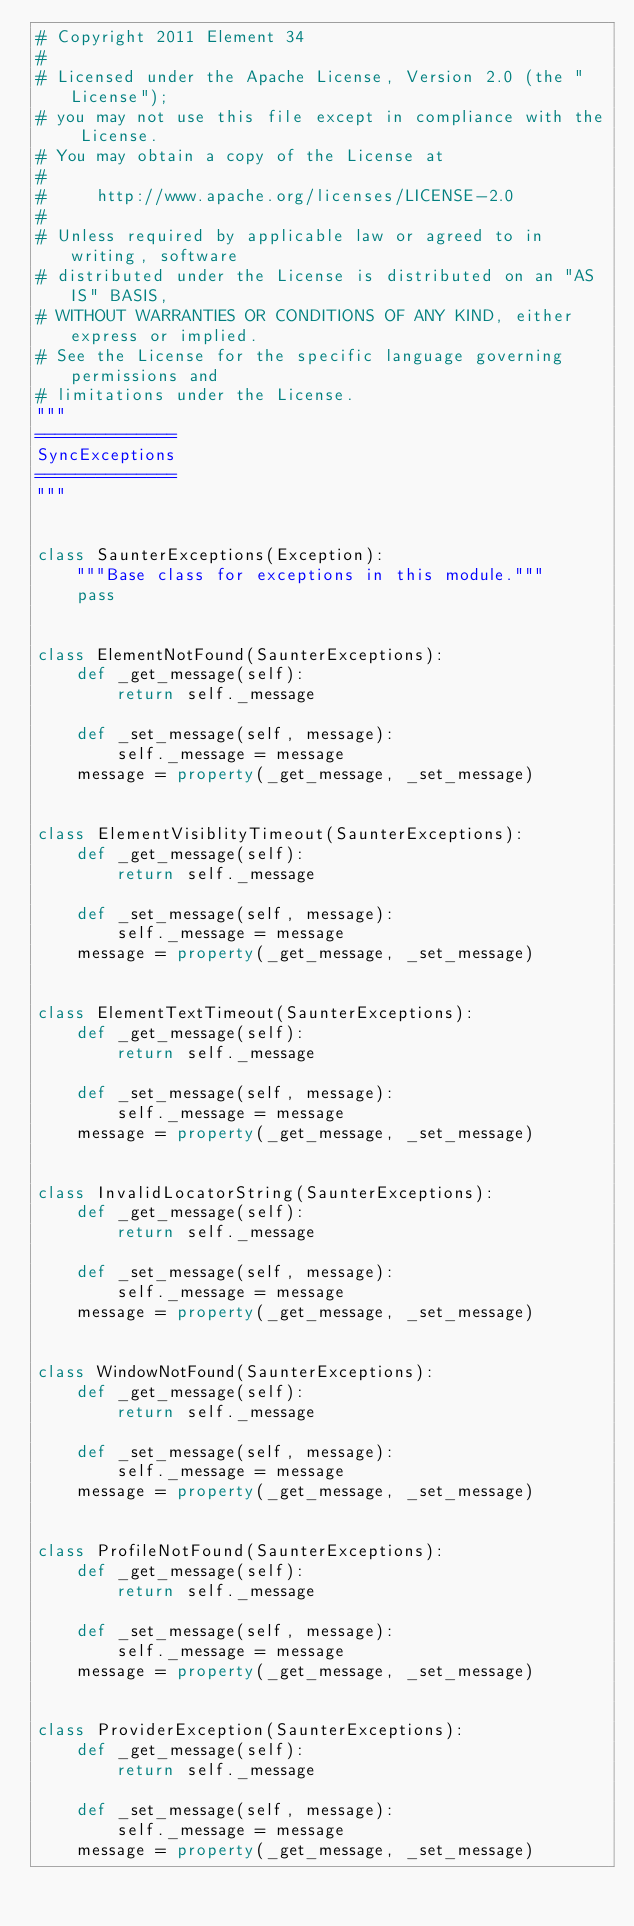Convert code to text. <code><loc_0><loc_0><loc_500><loc_500><_Python_># Copyright 2011 Element 34
#
# Licensed under the Apache License, Version 2.0 (the "License");
# you may not use this file except in compliance with the License.
# You may obtain a copy of the License at
#
#     http://www.apache.org/licenses/LICENSE-2.0
#
# Unless required by applicable law or agreed to in writing, software
# distributed under the License is distributed on an "AS IS" BASIS,
# WITHOUT WARRANTIES OR CONDITIONS OF ANY KIND, either express or implied.
# See the License for the specific language governing permissions and
# limitations under the License.
"""
==============
SyncExceptions
==============
"""


class SaunterExceptions(Exception):
    """Base class for exceptions in this module."""
    pass


class ElementNotFound(SaunterExceptions):
    def _get_message(self):
        return self._message

    def _set_message(self, message):
        self._message = message
    message = property(_get_message, _set_message)


class ElementVisiblityTimeout(SaunterExceptions):
    def _get_message(self):
        return self._message

    def _set_message(self, message):
        self._message = message
    message = property(_get_message, _set_message)


class ElementTextTimeout(SaunterExceptions):
    def _get_message(self):
        return self._message

    def _set_message(self, message):
        self._message = message
    message = property(_get_message, _set_message)


class InvalidLocatorString(SaunterExceptions):
    def _get_message(self):
        return self._message

    def _set_message(self, message):
        self._message = message
    message = property(_get_message, _set_message)


class WindowNotFound(SaunterExceptions):
    def _get_message(self):
        return self._message

    def _set_message(self, message):
        self._message = message
    message = property(_get_message, _set_message)


class ProfileNotFound(SaunterExceptions):
    def _get_message(self):
        return self._message

    def _set_message(self, message):
        self._message = message
    message = property(_get_message, _set_message)


class ProviderException(SaunterExceptions):
    def _get_message(self):
        return self._message

    def _set_message(self, message):
        self._message = message
    message = property(_get_message, _set_message)
</code> 